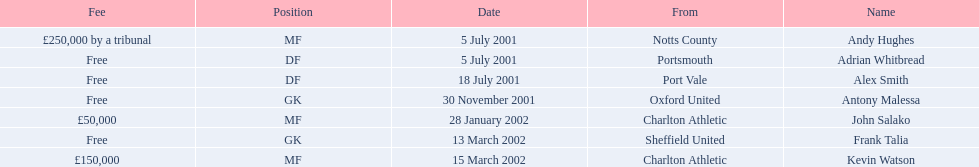What are the names of all the players? Andy Hughes, Adrian Whitbread, Alex Smith, Antony Malessa, John Salako, Frank Talia, Kevin Watson. What fee did andy hughes command? £250,000 by a tribunal. What fee did john salako command? £50,000. Which player had the highest fee, andy hughes or john salako? Andy Hughes. 